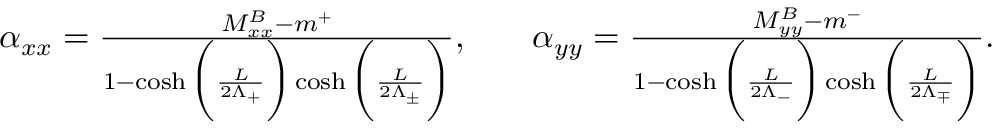<formula> <loc_0><loc_0><loc_500><loc_500>\begin{array} { r l r } { \alpha _ { x x } = \frac { M _ { x x } ^ { B } - m ^ { + } } { 1 - \cosh \left ( \frac { L } { 2 \Lambda _ { + } } \right ) \cosh \left ( \frac { L } { 2 \Lambda _ { \pm } } \right ) } , } & { \alpha _ { y y } = \frac { M _ { y y } ^ { B } - m ^ { - } } { 1 - \cosh \left ( \frac { L } { 2 \Lambda _ { - } } \right ) \cosh \left ( \frac { L } { 2 \Lambda _ { \mp } } \right ) } . } \end{array}</formula> 